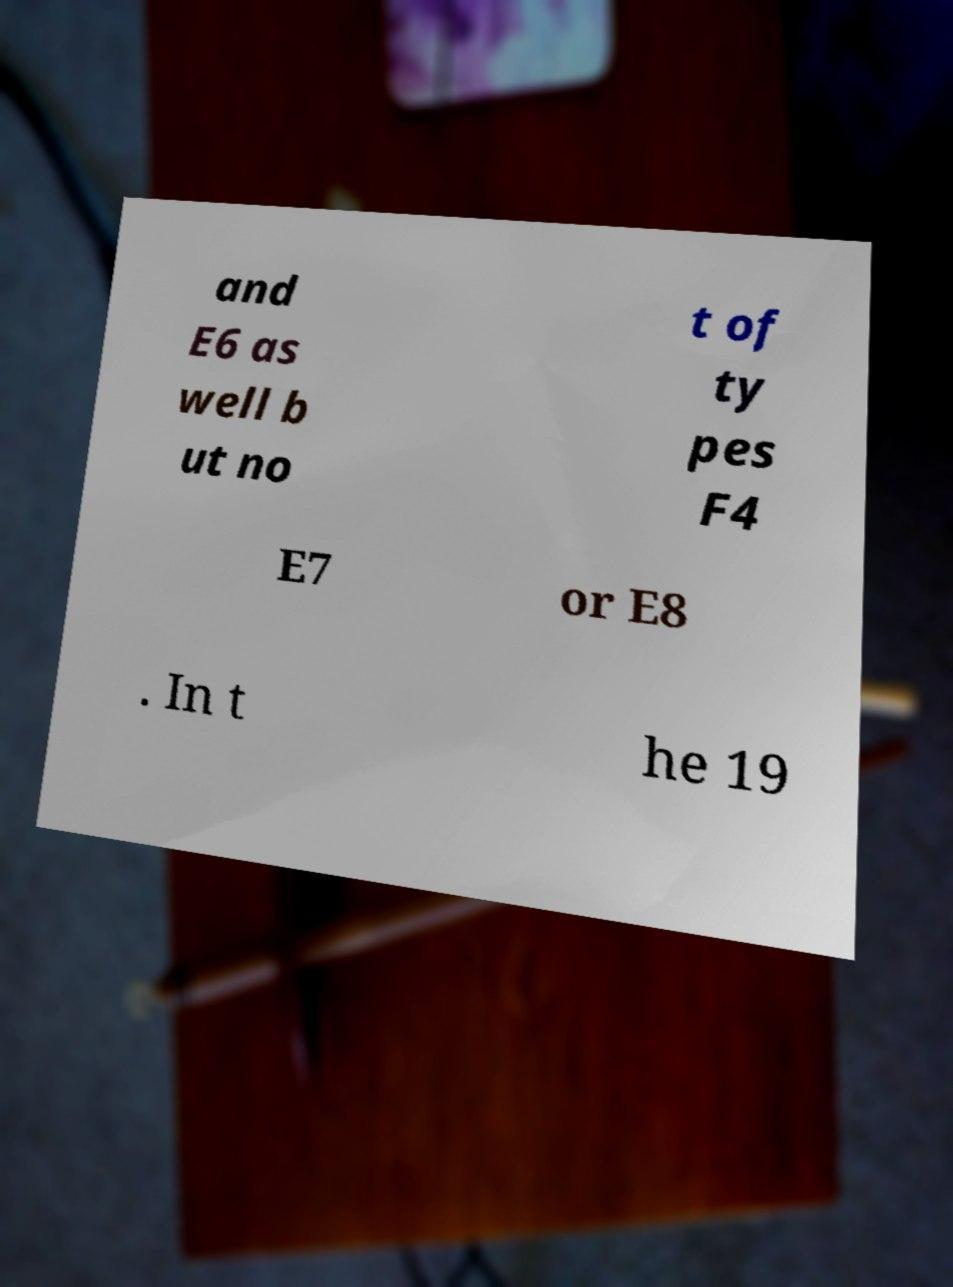There's text embedded in this image that I need extracted. Can you transcribe it verbatim? and E6 as well b ut no t of ty pes F4 E7 or E8 . In t he 19 